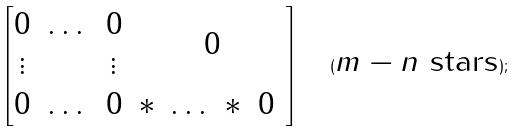Convert formula to latex. <formula><loc_0><loc_0><loc_500><loc_500>\begin{bmatrix} \begin{matrix} 0 & \dots & 0 \\ \vdots & & \vdots \end{matrix} & 0 \\ \begin{matrix} 0 & \dots & 0 \end{matrix} & \begin{matrix} * \ \dots \ * \ 0 \ \end{matrix} \end{bmatrix} \quad ( \text {$m-n$ stars} ) ;</formula> 